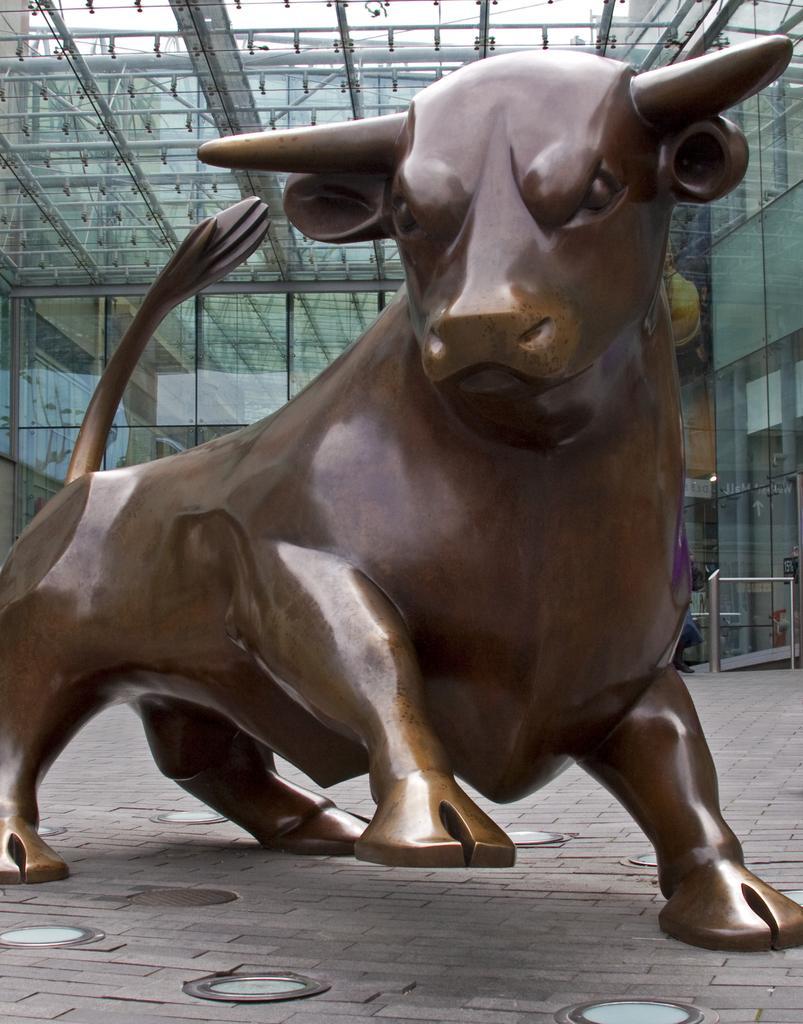In one or two sentences, can you explain what this image depicts? This picture seems to be clicked outside. In the foreground we can see the sculpture of an animal seems to be a bull. In the background we can see the metal rods, buildings, sky and the roof. 